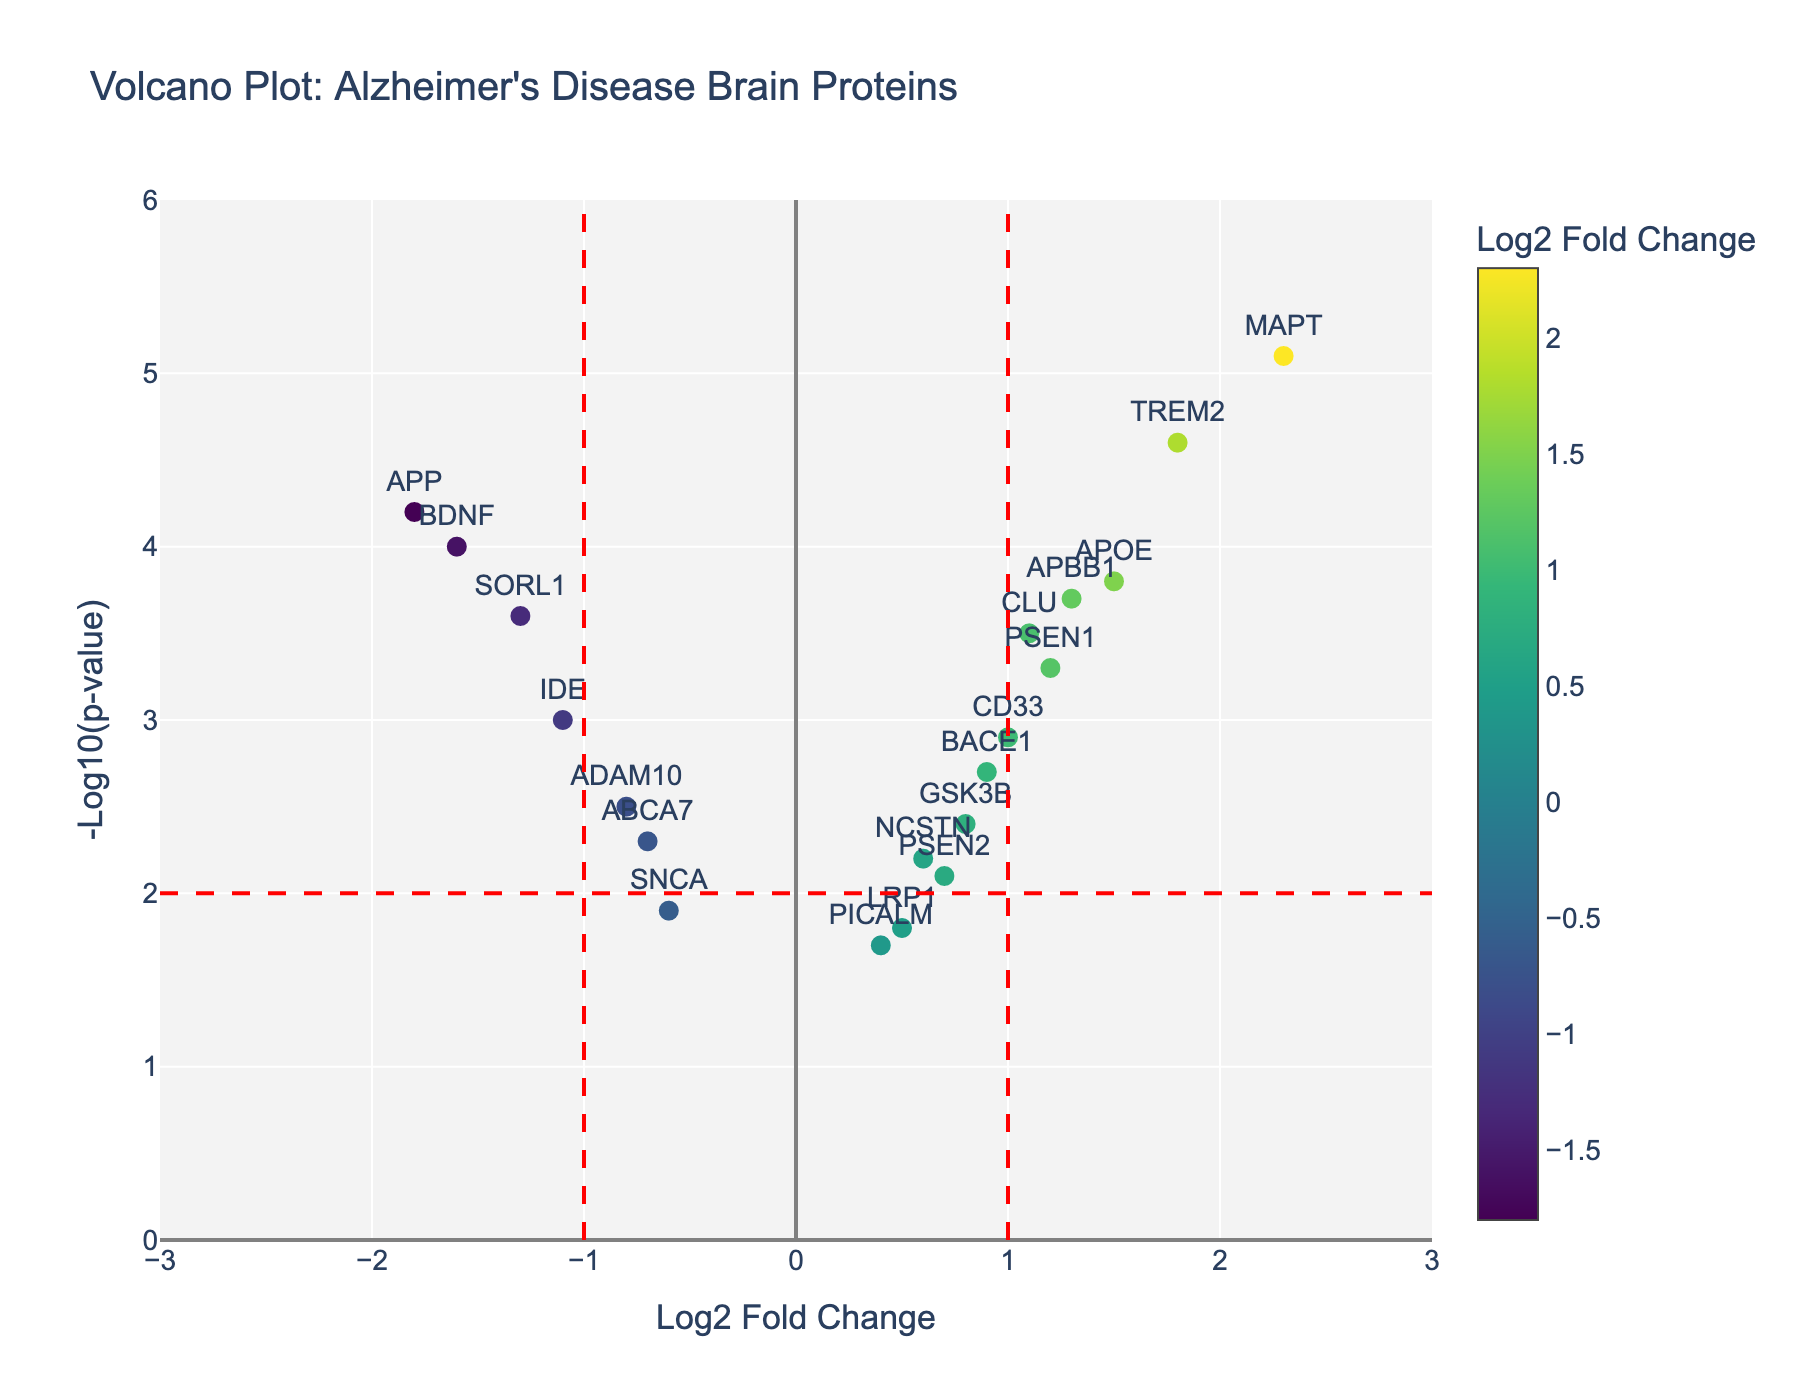What's the title of the plot? The title is displayed at the top of the plot and is a basic element that gives an overview of what the plot represents.
Answer: "Volcano Plot: Alzheimer's Disease Brain Proteins" How many proteins have a Log2 Fold Change greater than 1? To find this, count the data points to the right of the vertical line at Log2 Fold Change = 1.
Answer: 6 Which protein shows the highest -Log10(p-value)? To determine this, find the data point that is positioned at the highest point on the y-axis.
Answer: MAPT How many proteins are considered significantly altered based on a -Log10(p-value) threshold of 2 and Log2 Fold Change greater than 1? Calculate the number of proteins that lie above the horizontal line at -Log10(p-value) = 2 and to the right of the vertical line at Log2 Fold Change = 1.
Answer: 5 Which protein has the lowest Log2 Fold Change but is still above the significance threshold of -Log10(p-value) = 2? Find the data point with the smallest Log2 Fold Change value that lies above the horizontal line at -Log10(p-value) = 2.
Answer: APP What is the Log2 Fold Change and -Log10(p-value) of APOE? Locate the APOE data point and note its coordinates on the x and y axes.
Answer: Log2 Fold Change: 1.5, -Log10(p-value): 3.8 Are there more proteins with a positive or negative Log2 Fold Change above the significance threshold of -Log10(p-value) = 2? Count the number of data points with positive and negative Log2 Fold Change values that lie above the horizontal line at -Log10(p-value) = 2, respectively.
Answer: Positive Which proteins have a Log2 Fold Change of approximately 1 but are not significantly altered (-Log10(p-value) < 2)? Identify the data points around Log2 Fold Change of 1 and below -Log10(p-value) = 2.
Answer: BACE1, CLU What is the range of the -Log10(p-value) among the proteins displayed in the plot? The range is the difference between the highest and lowest -Log10(p-value) values visible on the y-axis.
Answer: 4.2 (5.1 - 0.9) How many proteins have a -Log10(p-value) between 3 and 5? Count the number of data points within the vertical range of -Log10(p-value) from 3 to 5.
Answer: 7 